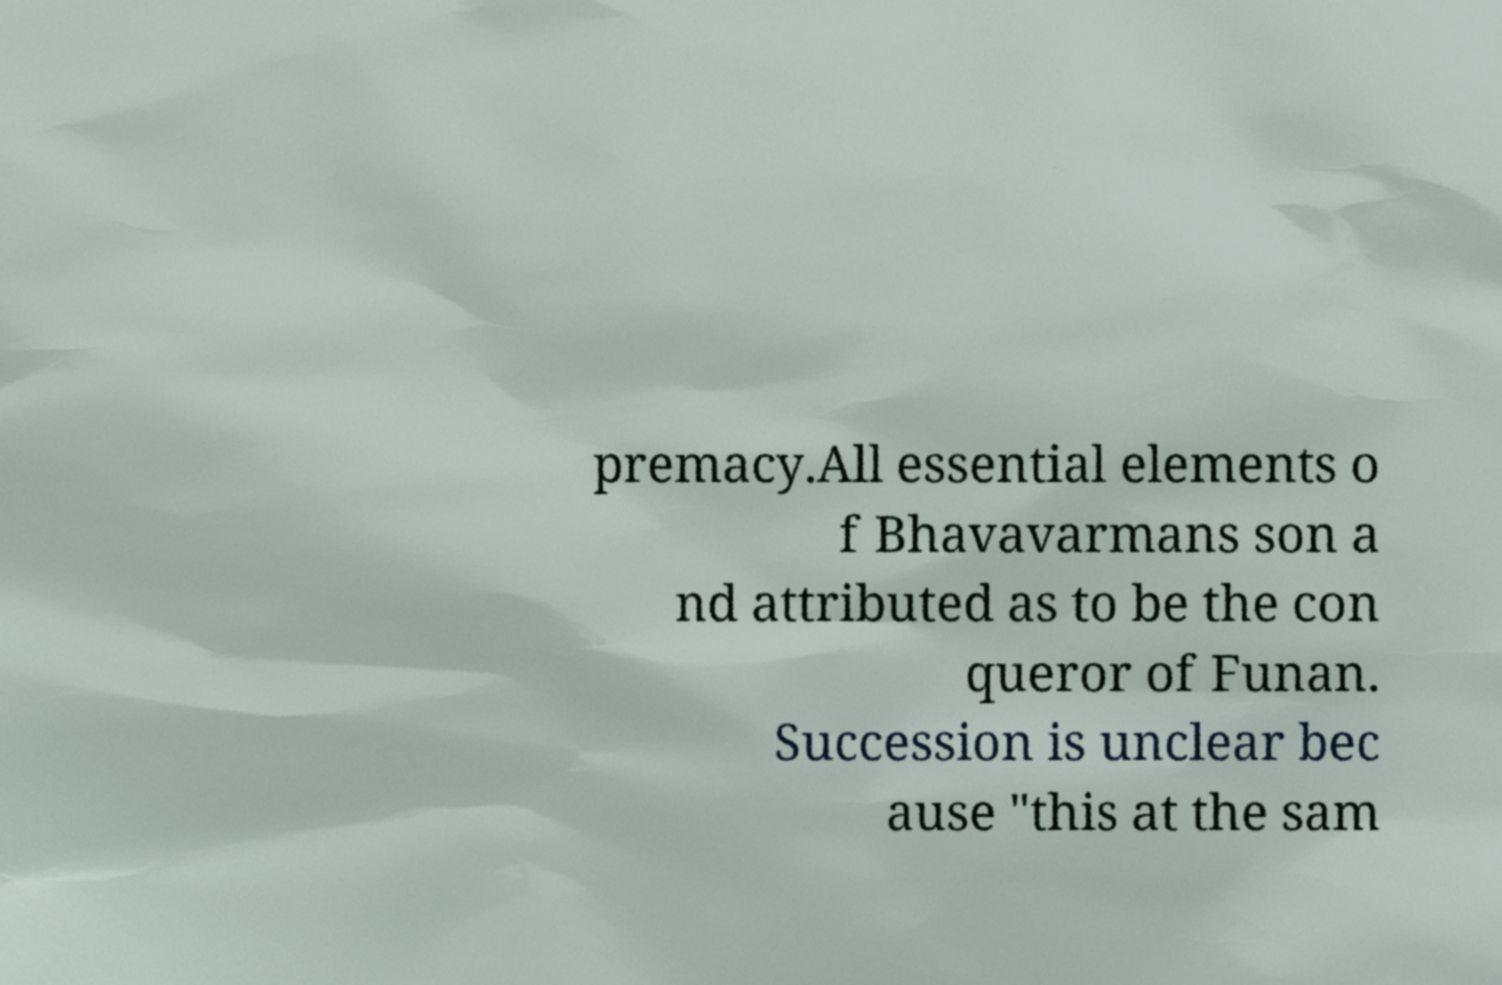There's text embedded in this image that I need extracted. Can you transcribe it verbatim? premacy.All essential elements o f Bhavavarmans son a nd attributed as to be the con queror of Funan. Succession is unclear bec ause "this at the sam 